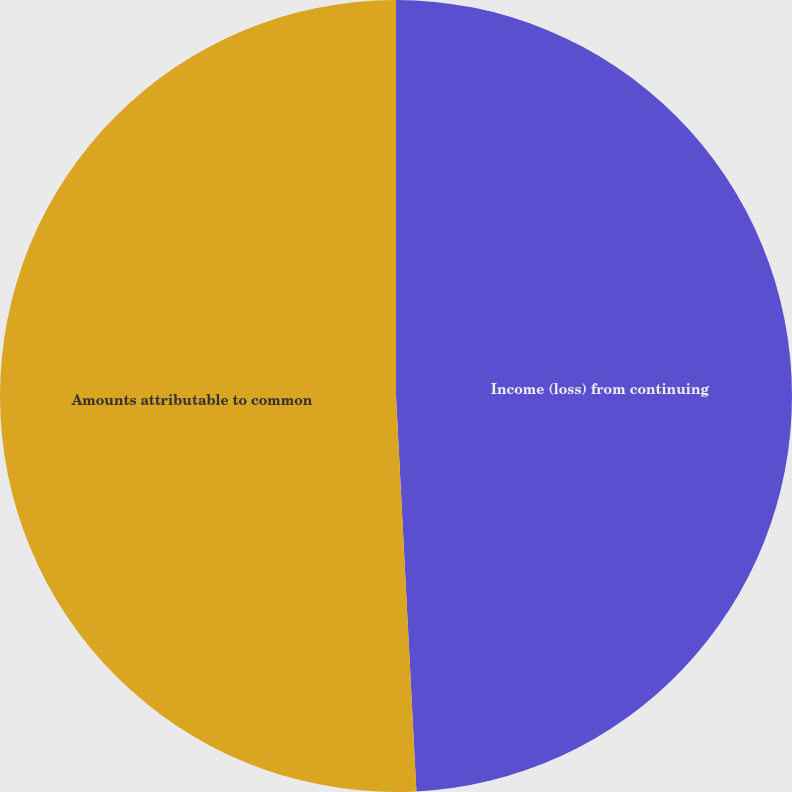Convert chart. <chart><loc_0><loc_0><loc_500><loc_500><pie_chart><fcel>Income (loss) from continuing<fcel>Amounts attributable to common<nl><fcel>49.18%<fcel>50.82%<nl></chart> 